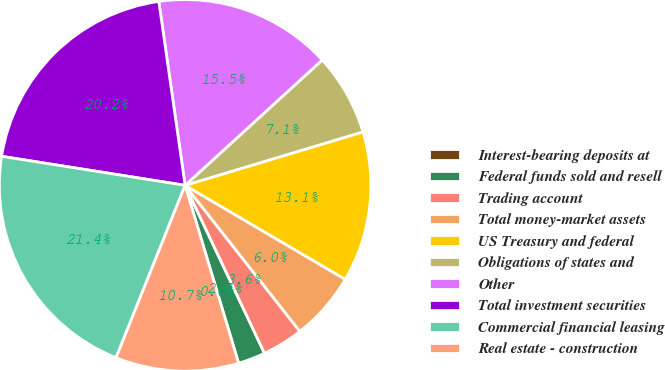Convert chart. <chart><loc_0><loc_0><loc_500><loc_500><pie_chart><fcel>Interest-bearing deposits at<fcel>Federal funds sold and resell<fcel>Trading account<fcel>Total money-market assets<fcel>US Treasury and federal<fcel>Obligations of states and<fcel>Other<fcel>Total investment securities<fcel>Commercial financial leasing<fcel>Real estate - construction<nl><fcel>0.0%<fcel>2.38%<fcel>3.57%<fcel>5.95%<fcel>13.09%<fcel>7.14%<fcel>15.47%<fcel>20.24%<fcel>21.43%<fcel>10.71%<nl></chart> 